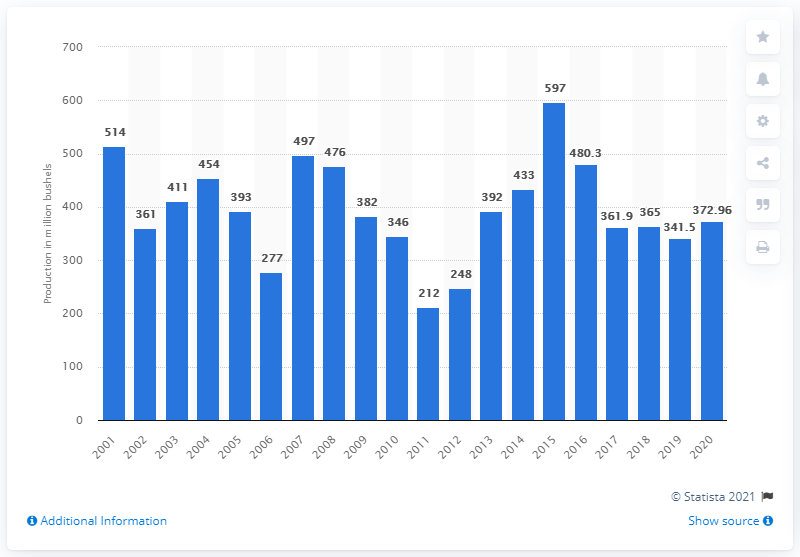Identify some key points in this picture. In 2020, the United States produced 372,960 bushels of sorghum. 